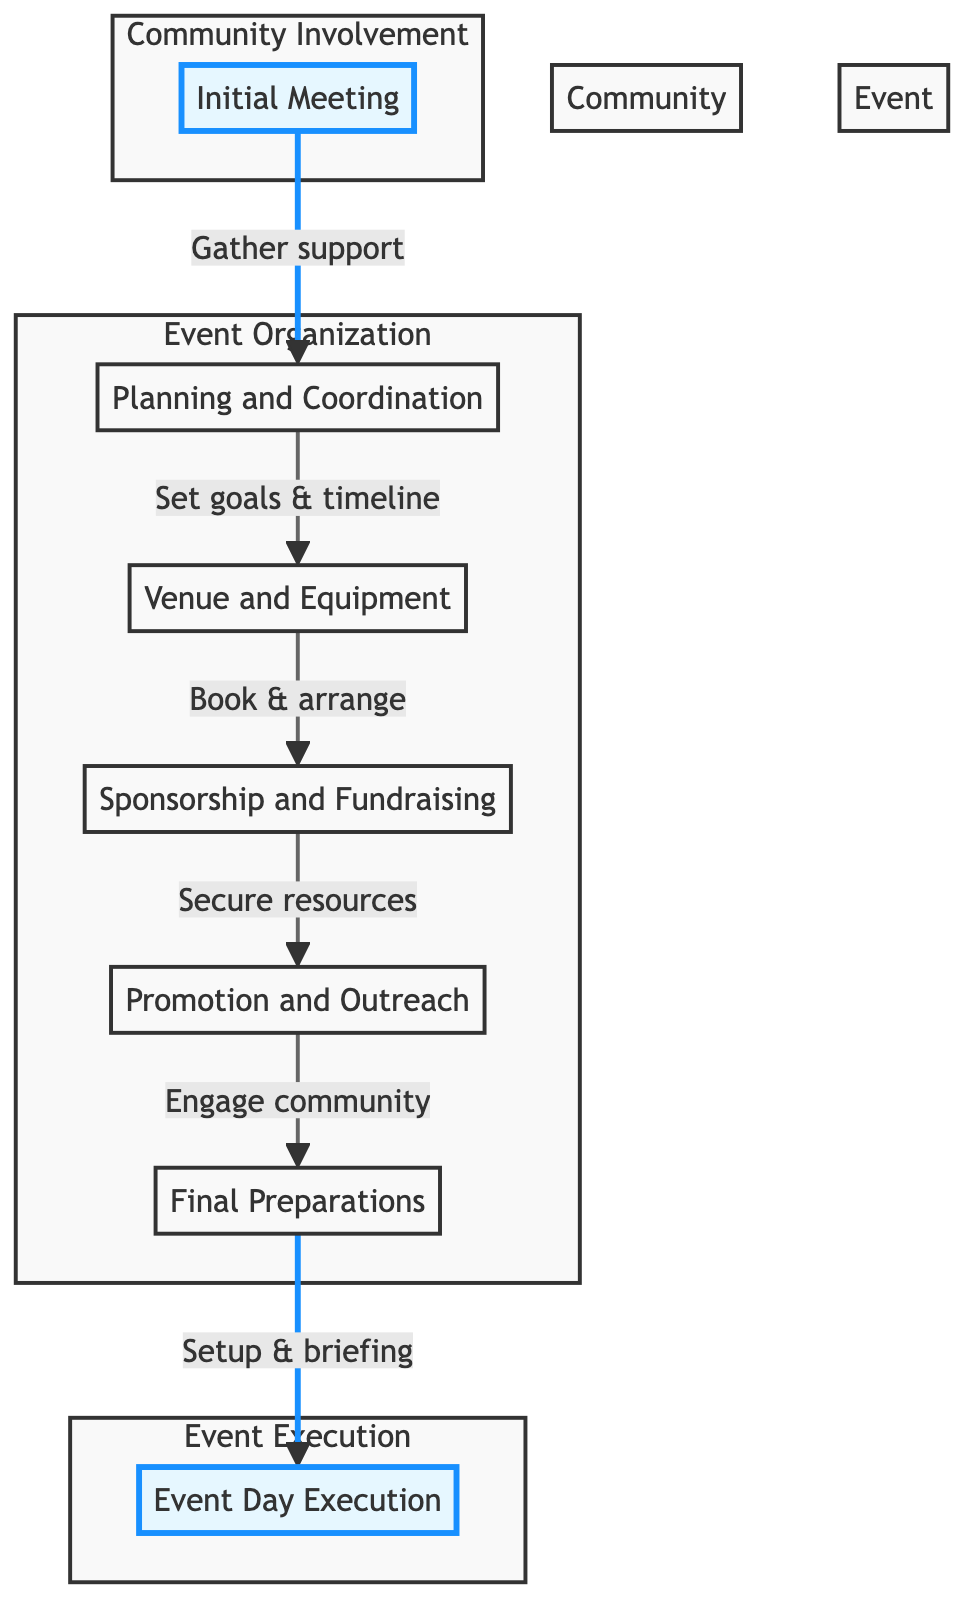What is the first step in setting up the event? The first step according to the diagram is the "Initial Meeting", where community members gather to discuss the idea and gather support.
Answer: Initial Meeting How many main steps are there from initial planning to event execution? Counting from "Initial Meeting" to "Event Day Execution", there are a total of six main steps in the flow.
Answer: Six What is the purpose of "Sponsorship and Fundraising"? The purpose of "Sponsorship and Fundraising" is to secure resources needed for the event by reaching out to local businesses and heritage clubs.
Answer: Secure resources Which step follows after "Final Preparations"? "Event Day Execution" follows after "Final Preparations" as the last step in the flow chart.
Answer: Event Day Execution What do the "Promotion and Outreach" activities involve? "Promotion and Outreach" involves engaging the community through local newspapers, social media, and posters in community centers.
Answer: Engaging the community Which two nodes are in the "Event Execution" subgraph? The only node in the "Event Execution" subgraph is "Event Day Execution". There are no other nodes in this section.
Answer: Event Day Execution What kind of entities are associated with "Planning and Coordination"? The entities associated with "Planning and Coordination" include an event committee, goals, an event timeline, and team roles.
Answer: Event committee, goals, event timeline, team roles Why is the "Initial Meeting" crucial for the event? The "Initial Meeting" is crucial as it serves as the foundational gathering to discuss the event idea, which is essential for gathering support from stakeholders and community members.
Answer: Gathering support What happens after "Venue and Equipment"? The next step after "Venue and Equipment" is "Sponsorship and Fundraising", which means securing finances and resources.
Answer: Sponsorship and Fundraising 